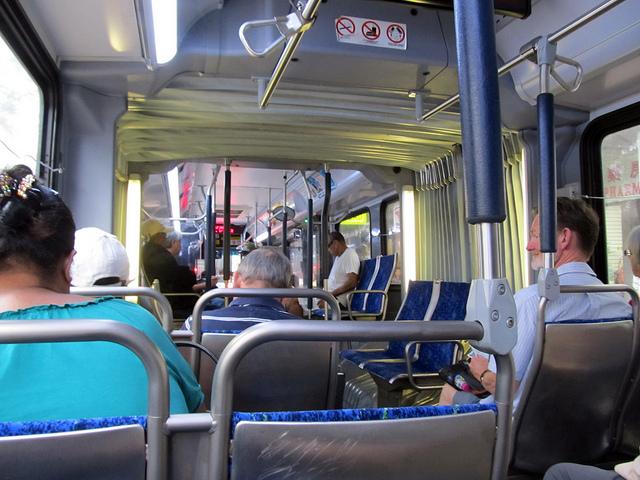Are these passengers underground?
Keep it brief. No. These are probably WWI soldiers?
Keep it brief. No. Where are the men sitting?
Concise answer only. Bus. Are all the seats occupied?
Short answer required. No. Is this a public transit vehicle?
Quick response, please. Yes. 